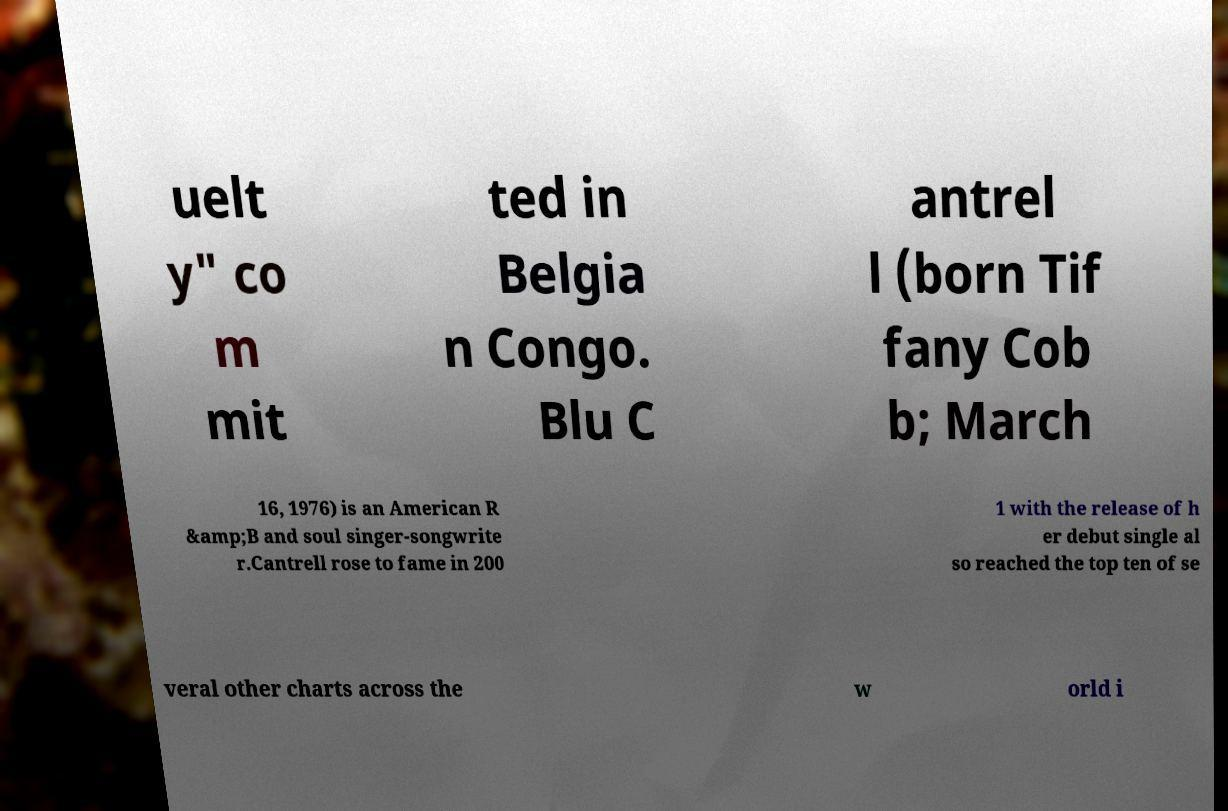I need the written content from this picture converted into text. Can you do that? uelt y" co m mit ted in Belgia n Congo. Blu C antrel l (born Tif fany Cob b; March 16, 1976) is an American R &amp;B and soul singer-songwrite r.Cantrell rose to fame in 200 1 with the release of h er debut single al so reached the top ten of se veral other charts across the w orld i 